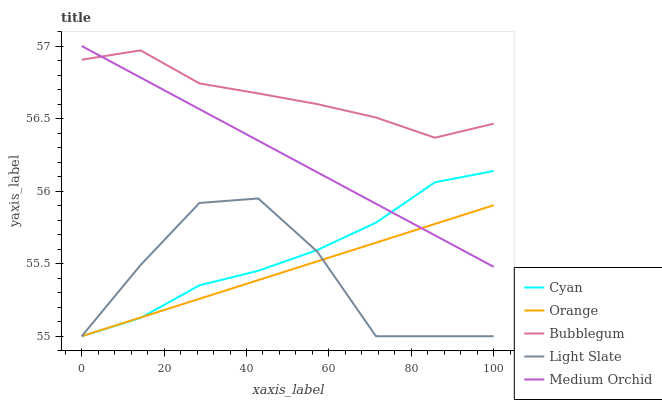Does Light Slate have the minimum area under the curve?
Answer yes or no. Yes. Does Bubblegum have the maximum area under the curve?
Answer yes or no. Yes. Does Cyan have the minimum area under the curve?
Answer yes or no. No. Does Cyan have the maximum area under the curve?
Answer yes or no. No. Is Medium Orchid the smoothest?
Answer yes or no. Yes. Is Light Slate the roughest?
Answer yes or no. Yes. Is Cyan the smoothest?
Answer yes or no. No. Is Cyan the roughest?
Answer yes or no. No. Does Orange have the lowest value?
Answer yes or no. Yes. Does Medium Orchid have the lowest value?
Answer yes or no. No. Does Medium Orchid have the highest value?
Answer yes or no. Yes. Does Cyan have the highest value?
Answer yes or no. No. Is Light Slate less than Medium Orchid?
Answer yes or no. Yes. Is Bubblegum greater than Orange?
Answer yes or no. Yes. Does Cyan intersect Medium Orchid?
Answer yes or no. Yes. Is Cyan less than Medium Orchid?
Answer yes or no. No. Is Cyan greater than Medium Orchid?
Answer yes or no. No. Does Light Slate intersect Medium Orchid?
Answer yes or no. No. 